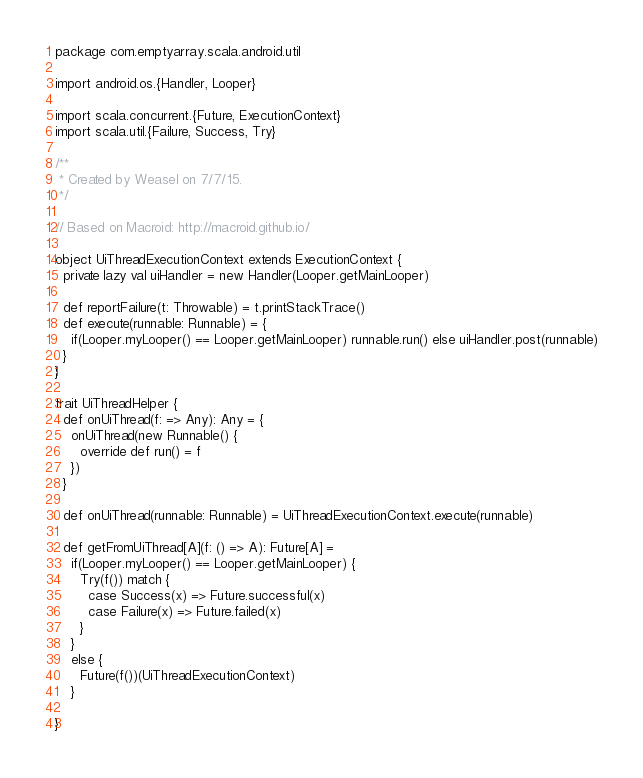<code> <loc_0><loc_0><loc_500><loc_500><_Scala_>package com.emptyarray.scala.android.util

import android.os.{Handler, Looper}

import scala.concurrent.{Future, ExecutionContext}
import scala.util.{Failure, Success, Try}

/**
 * Created by Weasel on 7/7/15.
 */

// Based on Macroid: http://macroid.github.io/

object UiThreadExecutionContext extends ExecutionContext {
  private lazy val uiHandler = new Handler(Looper.getMainLooper)

  def reportFailure(t: Throwable) = t.printStackTrace()
  def execute(runnable: Runnable) = {
    if(Looper.myLooper() == Looper.getMainLooper) runnable.run() else uiHandler.post(runnable)
  }
}

trait UiThreadHelper {
  def onUiThread(f: => Any): Any = {
    onUiThread(new Runnable() {
      override def run() = f
    })
  }

  def onUiThread(runnable: Runnable) = UiThreadExecutionContext.execute(runnable)

  def getFromUiThread[A](f: () => A): Future[A] =
    if(Looper.myLooper() == Looper.getMainLooper) {
      Try(f()) match {
        case Success(x) => Future.successful(x)
        case Failure(x) => Future.failed(x)
      }
    }
    else {
      Future(f())(UiThreadExecutionContext)
    }

}</code> 